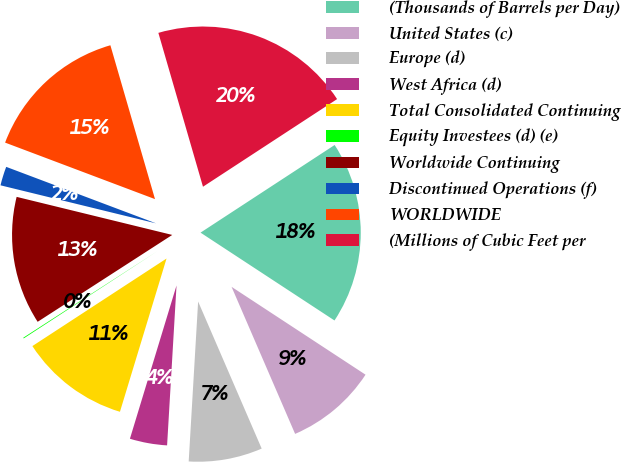<chart> <loc_0><loc_0><loc_500><loc_500><pie_chart><fcel>(Thousands of Barrels per Day)<fcel>United States (c)<fcel>Europe (d)<fcel>West Africa (d)<fcel>Total Consolidated Continuing<fcel>Equity Investees (d) (e)<fcel>Worldwide Continuing<fcel>Discontinued Operations (f)<fcel>WORLDWIDE<fcel>(Millions of Cubic Feet per<nl><fcel>18.45%<fcel>9.27%<fcel>7.43%<fcel>3.76%<fcel>11.1%<fcel>0.08%<fcel>12.94%<fcel>1.92%<fcel>14.77%<fcel>20.28%<nl></chart> 